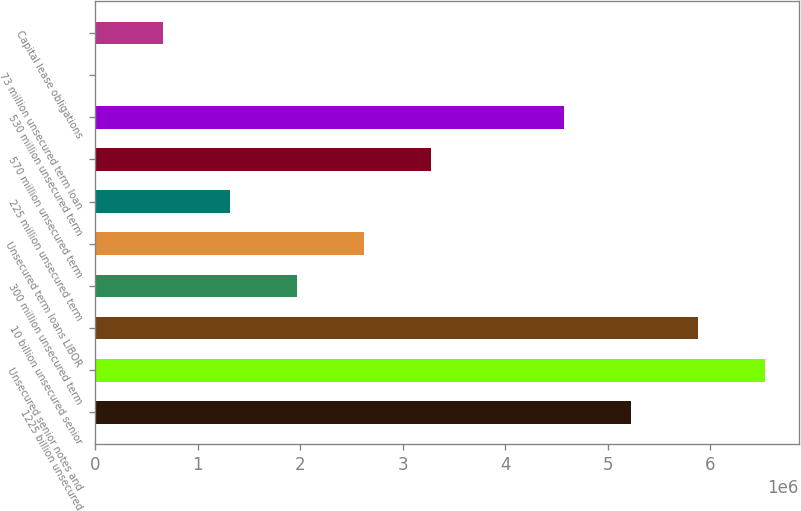Convert chart. <chart><loc_0><loc_0><loc_500><loc_500><bar_chart><fcel>1225 billion unsecured<fcel>Unsecured senior notes and<fcel>10 billion unsecured senior<fcel>300 million unsecured term<fcel>Unsecured term loans LIBOR<fcel>225 million unsecured term<fcel>570 million unsecured term<fcel>530 million unsecured term<fcel>73 million unsecured term loan<fcel>Capital lease obligations<nl><fcel>5.23284e+06<fcel>6.53951e+06<fcel>5.88618e+06<fcel>1.96618e+06<fcel>2.61951e+06<fcel>1.31285e+06<fcel>3.27284e+06<fcel>4.57951e+06<fcel>6179<fcel>659512<nl></chart> 